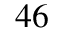<formula> <loc_0><loc_0><loc_500><loc_500>4 6</formula> 